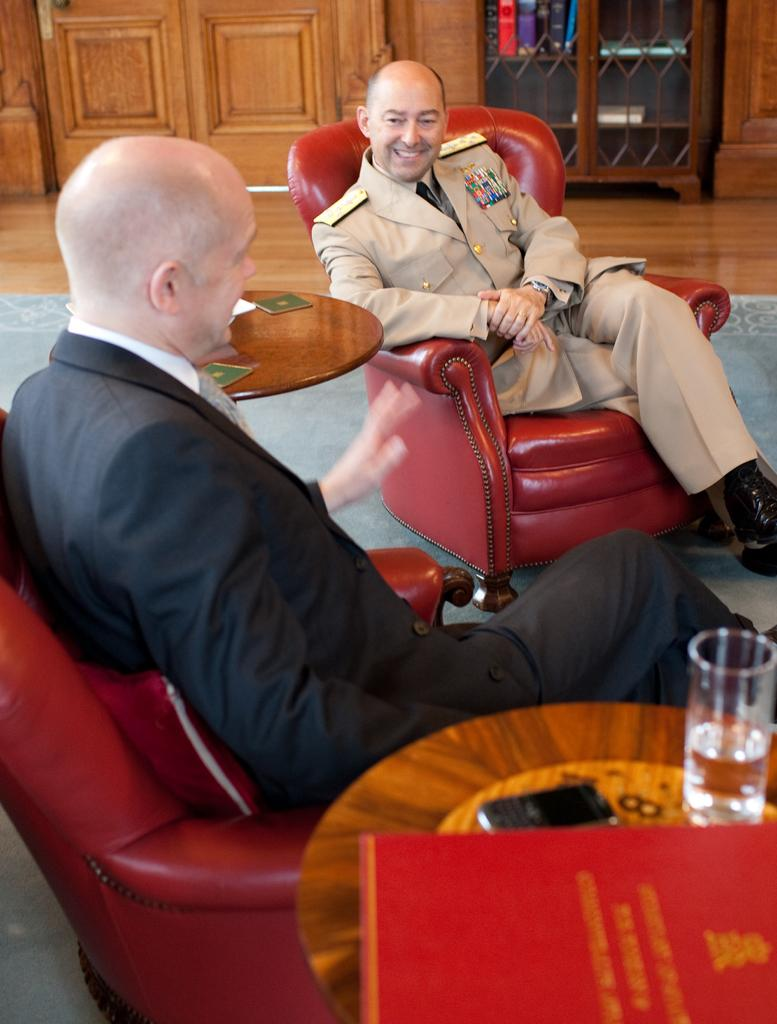How many people are in the image? There are two men in the image. What are the men doing in the image? The men are sitting on sofas. What can be seen on the table in the image? There is a water glass and a book on the table. What is visible in the background of the image? There is a wooden object in the background of the image. What type of orange is hanging from the ceiling in the image? There is no orange present in the image; it features two men sitting on sofas, a table with a water glass and a book, and a wooden object in the background. Is there a prison visible in the image? No, there is no prison present in the image. 